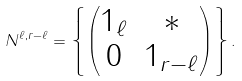<formula> <loc_0><loc_0><loc_500><loc_500>N ^ { \ell , r - \ell } = \left \{ \begin{pmatrix} 1 _ { \ell } & * \\ 0 & 1 _ { r - \ell } \end{pmatrix} \right \} .</formula> 